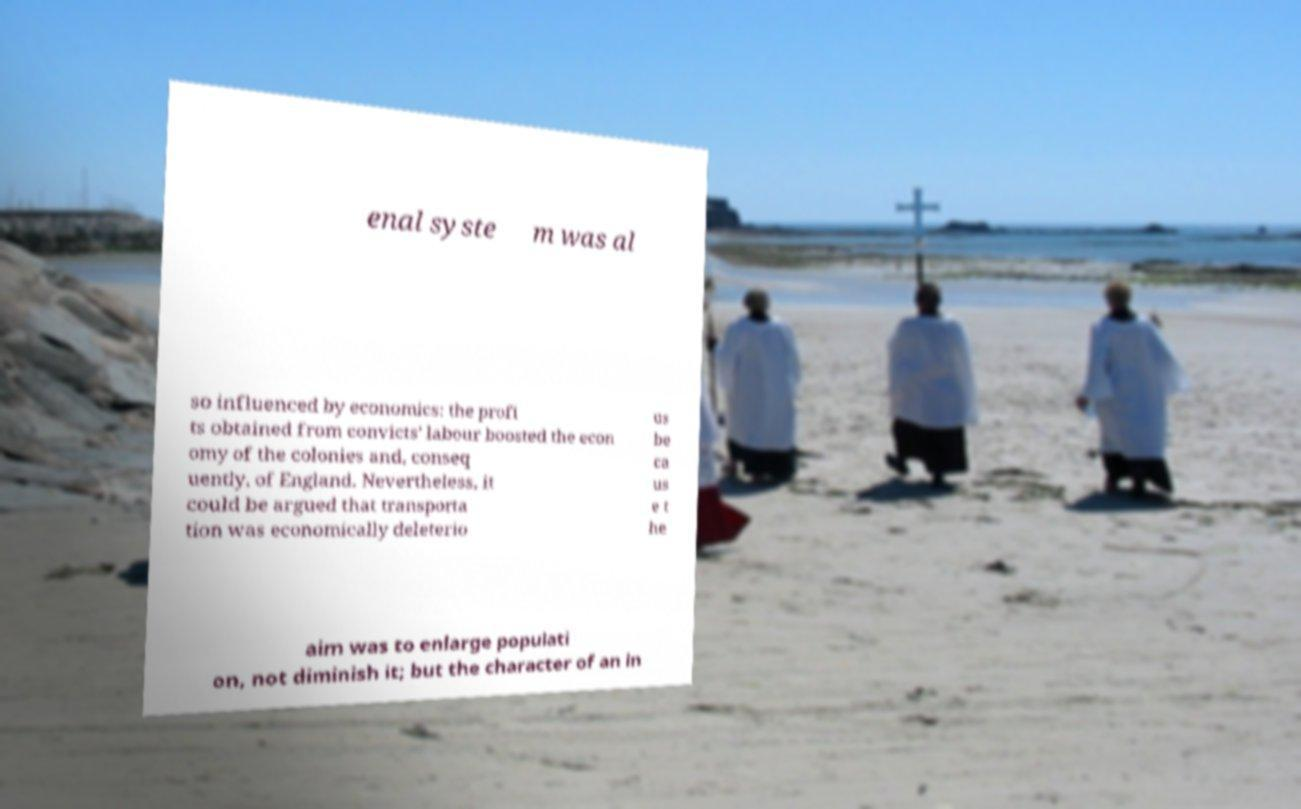I need the written content from this picture converted into text. Can you do that? enal syste m was al so influenced by economics: the profi ts obtained from convicts' labour boosted the econ omy of the colonies and, conseq uently, of England. Nevertheless, it could be argued that transporta tion was economically deleterio us be ca us e t he aim was to enlarge populati on, not diminish it; but the character of an in 